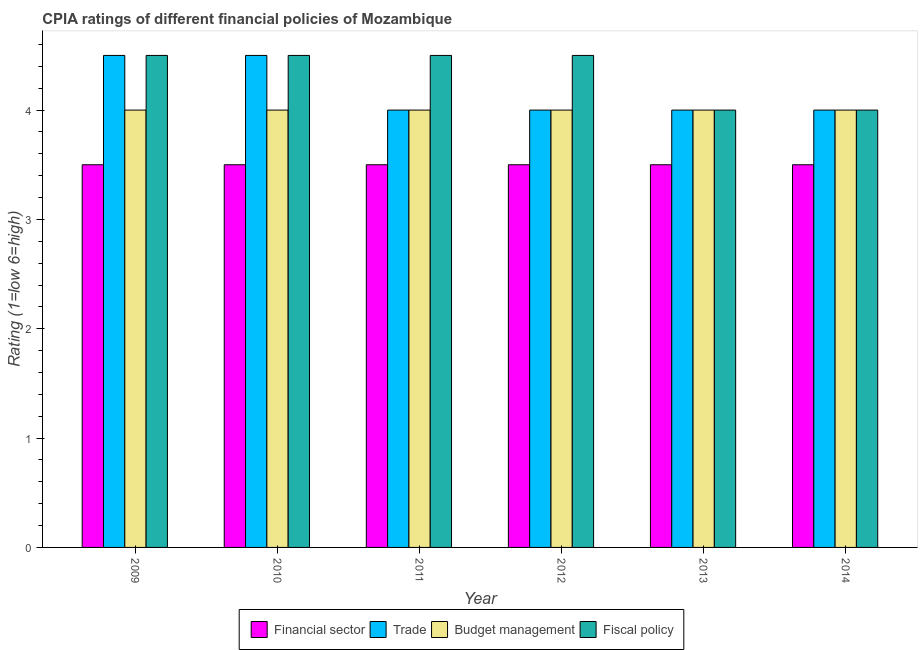How many different coloured bars are there?
Keep it short and to the point. 4. How many groups of bars are there?
Your answer should be very brief. 6. Are the number of bars per tick equal to the number of legend labels?
Offer a terse response. Yes. Are the number of bars on each tick of the X-axis equal?
Your answer should be very brief. Yes. How many bars are there on the 2nd tick from the left?
Give a very brief answer. 4. How many bars are there on the 5th tick from the right?
Provide a succinct answer. 4. What is the cpia rating of financial sector in 2010?
Provide a succinct answer. 3.5. Across all years, what is the maximum cpia rating of fiscal policy?
Provide a short and direct response. 4.5. Across all years, what is the minimum cpia rating of fiscal policy?
Your response must be concise. 4. What is the difference between the cpia rating of trade in 2010 and that in 2011?
Offer a very short reply. 0.5. What is the difference between the cpia rating of budget management in 2009 and the cpia rating of financial sector in 2010?
Offer a very short reply. 0. What is the average cpia rating of trade per year?
Keep it short and to the point. 4.17. Is the difference between the cpia rating of fiscal policy in 2010 and 2013 greater than the difference between the cpia rating of financial sector in 2010 and 2013?
Offer a very short reply. No. Is it the case that in every year, the sum of the cpia rating of fiscal policy and cpia rating of trade is greater than the sum of cpia rating of financial sector and cpia rating of budget management?
Offer a terse response. No. What does the 2nd bar from the left in 2011 represents?
Your response must be concise. Trade. What does the 4th bar from the right in 2012 represents?
Offer a terse response. Financial sector. Are all the bars in the graph horizontal?
Provide a succinct answer. No. Are the values on the major ticks of Y-axis written in scientific E-notation?
Give a very brief answer. No. Does the graph contain grids?
Your answer should be very brief. No. Where does the legend appear in the graph?
Your answer should be compact. Bottom center. How many legend labels are there?
Offer a very short reply. 4. How are the legend labels stacked?
Offer a terse response. Horizontal. What is the title of the graph?
Ensure brevity in your answer.  CPIA ratings of different financial policies of Mozambique. Does "Taxes on revenue" appear as one of the legend labels in the graph?
Provide a succinct answer. No. What is the label or title of the Y-axis?
Ensure brevity in your answer.  Rating (1=low 6=high). What is the Rating (1=low 6=high) in Financial sector in 2009?
Your answer should be compact. 3.5. What is the Rating (1=low 6=high) of Trade in 2009?
Give a very brief answer. 4.5. What is the Rating (1=low 6=high) of Fiscal policy in 2009?
Keep it short and to the point. 4.5. What is the Rating (1=low 6=high) of Financial sector in 2010?
Provide a succinct answer. 3.5. What is the Rating (1=low 6=high) of Budget management in 2010?
Your response must be concise. 4. What is the Rating (1=low 6=high) in Financial sector in 2011?
Give a very brief answer. 3.5. What is the Rating (1=low 6=high) of Trade in 2011?
Provide a short and direct response. 4. What is the Rating (1=low 6=high) of Budget management in 2011?
Provide a short and direct response. 4. What is the Rating (1=low 6=high) in Fiscal policy in 2011?
Offer a terse response. 4.5. What is the Rating (1=low 6=high) in Financial sector in 2012?
Keep it short and to the point. 3.5. What is the Rating (1=low 6=high) of Trade in 2012?
Provide a succinct answer. 4. What is the Rating (1=low 6=high) in Trade in 2013?
Provide a short and direct response. 4. What is the Rating (1=low 6=high) in Budget management in 2013?
Your answer should be compact. 4. What is the Rating (1=low 6=high) in Trade in 2014?
Keep it short and to the point. 4. What is the Rating (1=low 6=high) of Fiscal policy in 2014?
Your response must be concise. 4. Across all years, what is the maximum Rating (1=low 6=high) in Financial sector?
Your answer should be very brief. 3.5. Across all years, what is the maximum Rating (1=low 6=high) in Budget management?
Provide a short and direct response. 4. Across all years, what is the minimum Rating (1=low 6=high) of Fiscal policy?
Provide a short and direct response. 4. What is the total Rating (1=low 6=high) of Trade in the graph?
Keep it short and to the point. 25. What is the difference between the Rating (1=low 6=high) of Financial sector in 2009 and that in 2010?
Give a very brief answer. 0. What is the difference between the Rating (1=low 6=high) of Budget management in 2009 and that in 2010?
Make the answer very short. 0. What is the difference between the Rating (1=low 6=high) in Financial sector in 2009 and that in 2012?
Your response must be concise. 0. What is the difference between the Rating (1=low 6=high) of Trade in 2009 and that in 2012?
Your answer should be very brief. 0.5. What is the difference between the Rating (1=low 6=high) of Fiscal policy in 2009 and that in 2013?
Your answer should be compact. 0.5. What is the difference between the Rating (1=low 6=high) of Trade in 2009 and that in 2014?
Make the answer very short. 0.5. What is the difference between the Rating (1=low 6=high) in Budget management in 2009 and that in 2014?
Offer a terse response. 0. What is the difference between the Rating (1=low 6=high) in Fiscal policy in 2009 and that in 2014?
Make the answer very short. 0.5. What is the difference between the Rating (1=low 6=high) of Financial sector in 2010 and that in 2011?
Provide a succinct answer. 0. What is the difference between the Rating (1=low 6=high) in Trade in 2010 and that in 2011?
Keep it short and to the point. 0.5. What is the difference between the Rating (1=low 6=high) in Budget management in 2010 and that in 2011?
Provide a succinct answer. 0. What is the difference between the Rating (1=low 6=high) of Financial sector in 2010 and that in 2012?
Provide a succinct answer. 0. What is the difference between the Rating (1=low 6=high) in Trade in 2010 and that in 2012?
Your response must be concise. 0.5. What is the difference between the Rating (1=low 6=high) in Budget management in 2010 and that in 2012?
Give a very brief answer. 0. What is the difference between the Rating (1=low 6=high) in Fiscal policy in 2010 and that in 2012?
Provide a succinct answer. 0. What is the difference between the Rating (1=low 6=high) of Financial sector in 2010 and that in 2013?
Make the answer very short. 0. What is the difference between the Rating (1=low 6=high) in Trade in 2010 and that in 2013?
Your answer should be compact. 0.5. What is the difference between the Rating (1=low 6=high) in Budget management in 2010 and that in 2013?
Ensure brevity in your answer.  0. What is the difference between the Rating (1=low 6=high) of Financial sector in 2010 and that in 2014?
Keep it short and to the point. 0. What is the difference between the Rating (1=low 6=high) of Financial sector in 2011 and that in 2012?
Make the answer very short. 0. What is the difference between the Rating (1=low 6=high) in Trade in 2011 and that in 2012?
Provide a succinct answer. 0. What is the difference between the Rating (1=low 6=high) of Fiscal policy in 2011 and that in 2012?
Your answer should be compact. 0. What is the difference between the Rating (1=low 6=high) of Financial sector in 2011 and that in 2013?
Your answer should be very brief. 0. What is the difference between the Rating (1=low 6=high) of Budget management in 2011 and that in 2013?
Give a very brief answer. 0. What is the difference between the Rating (1=low 6=high) in Fiscal policy in 2011 and that in 2013?
Your answer should be very brief. 0.5. What is the difference between the Rating (1=low 6=high) in Financial sector in 2011 and that in 2014?
Offer a terse response. 0. What is the difference between the Rating (1=low 6=high) of Trade in 2011 and that in 2014?
Make the answer very short. 0. What is the difference between the Rating (1=low 6=high) of Budget management in 2012 and that in 2013?
Your answer should be compact. 0. What is the difference between the Rating (1=low 6=high) of Trade in 2012 and that in 2014?
Offer a terse response. 0. What is the difference between the Rating (1=low 6=high) in Financial sector in 2013 and that in 2014?
Provide a succinct answer. 0. What is the difference between the Rating (1=low 6=high) in Trade in 2013 and that in 2014?
Make the answer very short. 0. What is the difference between the Rating (1=low 6=high) of Budget management in 2009 and the Rating (1=low 6=high) of Fiscal policy in 2010?
Provide a short and direct response. -0.5. What is the difference between the Rating (1=low 6=high) of Financial sector in 2009 and the Rating (1=low 6=high) of Budget management in 2011?
Your answer should be compact. -0.5. What is the difference between the Rating (1=low 6=high) of Trade in 2009 and the Rating (1=low 6=high) of Budget management in 2011?
Keep it short and to the point. 0.5. What is the difference between the Rating (1=low 6=high) in Budget management in 2009 and the Rating (1=low 6=high) in Fiscal policy in 2011?
Keep it short and to the point. -0.5. What is the difference between the Rating (1=low 6=high) in Financial sector in 2009 and the Rating (1=low 6=high) in Trade in 2012?
Offer a terse response. -0.5. What is the difference between the Rating (1=low 6=high) in Financial sector in 2009 and the Rating (1=low 6=high) in Budget management in 2012?
Ensure brevity in your answer.  -0.5. What is the difference between the Rating (1=low 6=high) of Financial sector in 2009 and the Rating (1=low 6=high) of Fiscal policy in 2012?
Offer a terse response. -1. What is the difference between the Rating (1=low 6=high) in Trade in 2009 and the Rating (1=low 6=high) in Budget management in 2012?
Keep it short and to the point. 0.5. What is the difference between the Rating (1=low 6=high) in Budget management in 2009 and the Rating (1=low 6=high) in Fiscal policy in 2012?
Offer a very short reply. -0.5. What is the difference between the Rating (1=low 6=high) in Financial sector in 2009 and the Rating (1=low 6=high) in Trade in 2013?
Your answer should be very brief. -0.5. What is the difference between the Rating (1=low 6=high) of Financial sector in 2009 and the Rating (1=low 6=high) of Fiscal policy in 2013?
Ensure brevity in your answer.  -0.5. What is the difference between the Rating (1=low 6=high) in Trade in 2009 and the Rating (1=low 6=high) in Budget management in 2013?
Provide a short and direct response. 0.5. What is the difference between the Rating (1=low 6=high) of Trade in 2009 and the Rating (1=low 6=high) of Fiscal policy in 2013?
Offer a terse response. 0.5. What is the difference between the Rating (1=low 6=high) of Budget management in 2009 and the Rating (1=low 6=high) of Fiscal policy in 2014?
Ensure brevity in your answer.  0. What is the difference between the Rating (1=low 6=high) in Financial sector in 2010 and the Rating (1=low 6=high) in Budget management in 2011?
Your answer should be very brief. -0.5. What is the difference between the Rating (1=low 6=high) of Trade in 2010 and the Rating (1=low 6=high) of Fiscal policy in 2011?
Your response must be concise. 0. What is the difference between the Rating (1=low 6=high) in Budget management in 2010 and the Rating (1=low 6=high) in Fiscal policy in 2011?
Offer a very short reply. -0.5. What is the difference between the Rating (1=low 6=high) in Trade in 2010 and the Rating (1=low 6=high) in Fiscal policy in 2012?
Keep it short and to the point. 0. What is the difference between the Rating (1=low 6=high) in Financial sector in 2010 and the Rating (1=low 6=high) in Budget management in 2013?
Offer a terse response. -0.5. What is the difference between the Rating (1=low 6=high) of Financial sector in 2010 and the Rating (1=low 6=high) of Fiscal policy in 2013?
Provide a short and direct response. -0.5. What is the difference between the Rating (1=low 6=high) in Trade in 2010 and the Rating (1=low 6=high) in Budget management in 2013?
Your answer should be compact. 0.5. What is the difference between the Rating (1=low 6=high) in Trade in 2010 and the Rating (1=low 6=high) in Fiscal policy in 2013?
Provide a short and direct response. 0.5. What is the difference between the Rating (1=low 6=high) in Financial sector in 2010 and the Rating (1=low 6=high) in Trade in 2014?
Keep it short and to the point. -0.5. What is the difference between the Rating (1=low 6=high) in Financial sector in 2010 and the Rating (1=low 6=high) in Fiscal policy in 2014?
Provide a short and direct response. -0.5. What is the difference between the Rating (1=low 6=high) of Trade in 2010 and the Rating (1=low 6=high) of Budget management in 2014?
Give a very brief answer. 0.5. What is the difference between the Rating (1=low 6=high) in Trade in 2010 and the Rating (1=low 6=high) in Fiscal policy in 2014?
Offer a very short reply. 0.5. What is the difference between the Rating (1=low 6=high) in Budget management in 2010 and the Rating (1=low 6=high) in Fiscal policy in 2014?
Your answer should be very brief. 0. What is the difference between the Rating (1=low 6=high) of Trade in 2011 and the Rating (1=low 6=high) of Fiscal policy in 2012?
Ensure brevity in your answer.  -0.5. What is the difference between the Rating (1=low 6=high) in Trade in 2011 and the Rating (1=low 6=high) in Budget management in 2013?
Keep it short and to the point. 0. What is the difference between the Rating (1=low 6=high) of Budget management in 2011 and the Rating (1=low 6=high) of Fiscal policy in 2013?
Ensure brevity in your answer.  0. What is the difference between the Rating (1=low 6=high) in Financial sector in 2011 and the Rating (1=low 6=high) in Trade in 2014?
Offer a terse response. -0.5. What is the difference between the Rating (1=low 6=high) in Trade in 2011 and the Rating (1=low 6=high) in Budget management in 2014?
Offer a terse response. 0. What is the difference between the Rating (1=low 6=high) in Trade in 2011 and the Rating (1=low 6=high) in Fiscal policy in 2014?
Offer a very short reply. 0. What is the difference between the Rating (1=low 6=high) of Trade in 2012 and the Rating (1=low 6=high) of Budget management in 2013?
Your response must be concise. 0. What is the difference between the Rating (1=low 6=high) in Trade in 2012 and the Rating (1=low 6=high) in Fiscal policy in 2013?
Provide a short and direct response. 0. What is the difference between the Rating (1=low 6=high) in Trade in 2012 and the Rating (1=low 6=high) in Budget management in 2014?
Keep it short and to the point. 0. What is the difference between the Rating (1=low 6=high) of Trade in 2012 and the Rating (1=low 6=high) of Fiscal policy in 2014?
Ensure brevity in your answer.  0. What is the difference between the Rating (1=low 6=high) in Financial sector in 2013 and the Rating (1=low 6=high) in Trade in 2014?
Give a very brief answer. -0.5. What is the difference between the Rating (1=low 6=high) of Financial sector in 2013 and the Rating (1=low 6=high) of Budget management in 2014?
Offer a terse response. -0.5. What is the difference between the Rating (1=low 6=high) of Trade in 2013 and the Rating (1=low 6=high) of Fiscal policy in 2014?
Provide a succinct answer. 0. What is the difference between the Rating (1=low 6=high) of Budget management in 2013 and the Rating (1=low 6=high) of Fiscal policy in 2014?
Your response must be concise. 0. What is the average Rating (1=low 6=high) of Trade per year?
Offer a terse response. 4.17. What is the average Rating (1=low 6=high) of Budget management per year?
Your answer should be very brief. 4. What is the average Rating (1=low 6=high) of Fiscal policy per year?
Your answer should be very brief. 4.33. In the year 2009, what is the difference between the Rating (1=low 6=high) of Financial sector and Rating (1=low 6=high) of Fiscal policy?
Keep it short and to the point. -1. In the year 2009, what is the difference between the Rating (1=low 6=high) of Trade and Rating (1=low 6=high) of Fiscal policy?
Give a very brief answer. 0. In the year 2010, what is the difference between the Rating (1=low 6=high) of Financial sector and Rating (1=low 6=high) of Trade?
Your answer should be very brief. -1. In the year 2010, what is the difference between the Rating (1=low 6=high) of Trade and Rating (1=low 6=high) of Fiscal policy?
Your answer should be compact. 0. In the year 2011, what is the difference between the Rating (1=low 6=high) in Financial sector and Rating (1=low 6=high) in Budget management?
Offer a terse response. -0.5. In the year 2011, what is the difference between the Rating (1=low 6=high) in Trade and Rating (1=low 6=high) in Budget management?
Keep it short and to the point. 0. In the year 2011, what is the difference between the Rating (1=low 6=high) of Budget management and Rating (1=low 6=high) of Fiscal policy?
Make the answer very short. -0.5. In the year 2012, what is the difference between the Rating (1=low 6=high) of Financial sector and Rating (1=low 6=high) of Trade?
Provide a succinct answer. -0.5. In the year 2012, what is the difference between the Rating (1=low 6=high) of Financial sector and Rating (1=low 6=high) of Fiscal policy?
Provide a short and direct response. -1. In the year 2012, what is the difference between the Rating (1=low 6=high) of Trade and Rating (1=low 6=high) of Budget management?
Your answer should be very brief. 0. In the year 2012, what is the difference between the Rating (1=low 6=high) in Trade and Rating (1=low 6=high) in Fiscal policy?
Offer a very short reply. -0.5. In the year 2013, what is the difference between the Rating (1=low 6=high) in Financial sector and Rating (1=low 6=high) in Trade?
Keep it short and to the point. -0.5. In the year 2013, what is the difference between the Rating (1=low 6=high) in Financial sector and Rating (1=low 6=high) in Fiscal policy?
Provide a succinct answer. -0.5. In the year 2013, what is the difference between the Rating (1=low 6=high) in Trade and Rating (1=low 6=high) in Fiscal policy?
Keep it short and to the point. 0. In the year 2013, what is the difference between the Rating (1=low 6=high) of Budget management and Rating (1=low 6=high) of Fiscal policy?
Keep it short and to the point. 0. In the year 2014, what is the difference between the Rating (1=low 6=high) of Financial sector and Rating (1=low 6=high) of Trade?
Your response must be concise. -0.5. In the year 2014, what is the difference between the Rating (1=low 6=high) in Financial sector and Rating (1=low 6=high) in Budget management?
Give a very brief answer. -0.5. In the year 2014, what is the difference between the Rating (1=low 6=high) in Trade and Rating (1=low 6=high) in Budget management?
Offer a very short reply. 0. In the year 2014, what is the difference between the Rating (1=low 6=high) in Trade and Rating (1=low 6=high) in Fiscal policy?
Provide a succinct answer. 0. In the year 2014, what is the difference between the Rating (1=low 6=high) of Budget management and Rating (1=low 6=high) of Fiscal policy?
Your answer should be very brief. 0. What is the ratio of the Rating (1=low 6=high) of Budget management in 2009 to that in 2010?
Keep it short and to the point. 1. What is the ratio of the Rating (1=low 6=high) in Fiscal policy in 2009 to that in 2010?
Your answer should be very brief. 1. What is the ratio of the Rating (1=low 6=high) in Financial sector in 2009 to that in 2011?
Ensure brevity in your answer.  1. What is the ratio of the Rating (1=low 6=high) in Financial sector in 2009 to that in 2012?
Keep it short and to the point. 1. What is the ratio of the Rating (1=low 6=high) of Budget management in 2009 to that in 2012?
Offer a very short reply. 1. What is the ratio of the Rating (1=low 6=high) in Fiscal policy in 2009 to that in 2012?
Ensure brevity in your answer.  1. What is the ratio of the Rating (1=low 6=high) in Budget management in 2009 to that in 2013?
Offer a terse response. 1. What is the ratio of the Rating (1=low 6=high) in Budget management in 2009 to that in 2014?
Your response must be concise. 1. What is the ratio of the Rating (1=low 6=high) of Trade in 2010 to that in 2011?
Your response must be concise. 1.12. What is the ratio of the Rating (1=low 6=high) of Budget management in 2010 to that in 2011?
Make the answer very short. 1. What is the ratio of the Rating (1=low 6=high) in Trade in 2010 to that in 2012?
Your answer should be compact. 1.12. What is the ratio of the Rating (1=low 6=high) of Financial sector in 2010 to that in 2013?
Provide a short and direct response. 1. What is the ratio of the Rating (1=low 6=high) of Fiscal policy in 2010 to that in 2013?
Provide a succinct answer. 1.12. What is the ratio of the Rating (1=low 6=high) of Trade in 2010 to that in 2014?
Provide a short and direct response. 1.12. What is the ratio of the Rating (1=low 6=high) of Fiscal policy in 2010 to that in 2014?
Keep it short and to the point. 1.12. What is the ratio of the Rating (1=low 6=high) in Financial sector in 2011 to that in 2012?
Your answer should be compact. 1. What is the ratio of the Rating (1=low 6=high) of Trade in 2011 to that in 2012?
Your answer should be very brief. 1. What is the ratio of the Rating (1=low 6=high) in Fiscal policy in 2011 to that in 2012?
Give a very brief answer. 1. What is the ratio of the Rating (1=low 6=high) of Fiscal policy in 2011 to that in 2013?
Your answer should be compact. 1.12. What is the ratio of the Rating (1=low 6=high) of Trade in 2011 to that in 2014?
Ensure brevity in your answer.  1. What is the ratio of the Rating (1=low 6=high) of Fiscal policy in 2012 to that in 2013?
Your answer should be compact. 1.12. What is the ratio of the Rating (1=low 6=high) of Fiscal policy in 2012 to that in 2014?
Give a very brief answer. 1.12. What is the ratio of the Rating (1=low 6=high) in Trade in 2013 to that in 2014?
Offer a terse response. 1. What is the ratio of the Rating (1=low 6=high) of Budget management in 2013 to that in 2014?
Provide a short and direct response. 1. What is the ratio of the Rating (1=low 6=high) of Fiscal policy in 2013 to that in 2014?
Your answer should be very brief. 1. What is the difference between the highest and the second highest Rating (1=low 6=high) in Trade?
Your answer should be compact. 0. What is the difference between the highest and the second highest Rating (1=low 6=high) of Fiscal policy?
Offer a terse response. 0. What is the difference between the highest and the lowest Rating (1=low 6=high) in Financial sector?
Your response must be concise. 0. What is the difference between the highest and the lowest Rating (1=low 6=high) in Fiscal policy?
Offer a very short reply. 0.5. 